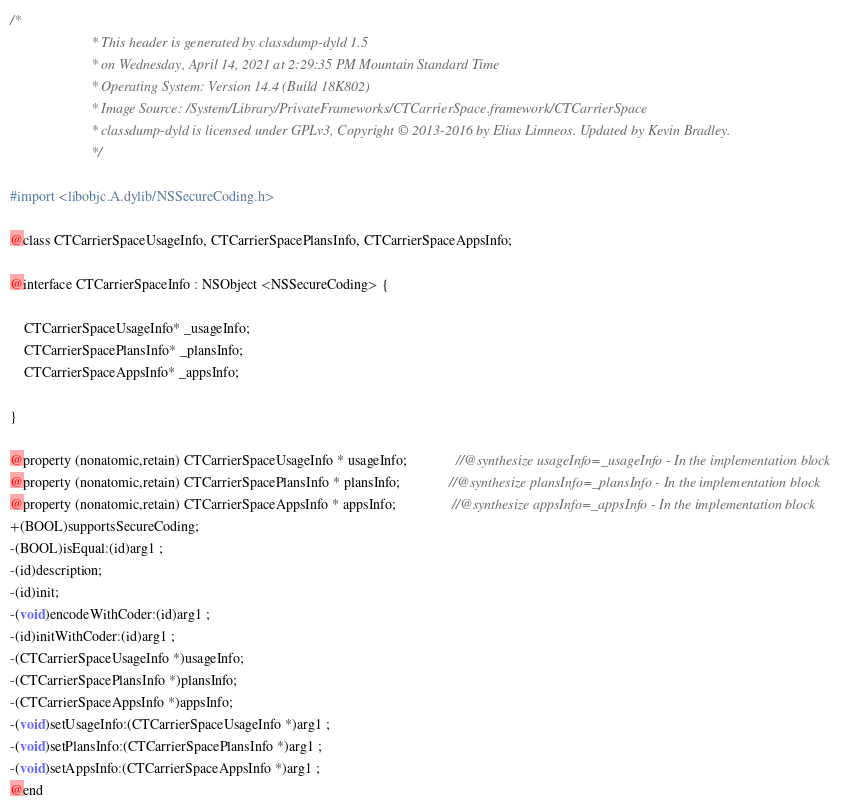Convert code to text. <code><loc_0><loc_0><loc_500><loc_500><_C_>/*
                       * This header is generated by classdump-dyld 1.5
                       * on Wednesday, April 14, 2021 at 2:29:35 PM Mountain Standard Time
                       * Operating System: Version 14.4 (Build 18K802)
                       * Image Source: /System/Library/PrivateFrameworks/CTCarrierSpace.framework/CTCarrierSpace
                       * classdump-dyld is licensed under GPLv3, Copyright © 2013-2016 by Elias Limneos. Updated by Kevin Bradley.
                       */

#import <libobjc.A.dylib/NSSecureCoding.h>

@class CTCarrierSpaceUsageInfo, CTCarrierSpacePlansInfo, CTCarrierSpaceAppsInfo;

@interface CTCarrierSpaceInfo : NSObject <NSSecureCoding> {

	CTCarrierSpaceUsageInfo* _usageInfo;
	CTCarrierSpacePlansInfo* _plansInfo;
	CTCarrierSpaceAppsInfo* _appsInfo;

}

@property (nonatomic,retain) CTCarrierSpaceUsageInfo * usageInfo;              //@synthesize usageInfo=_usageInfo - In the implementation block
@property (nonatomic,retain) CTCarrierSpacePlansInfo * plansInfo;              //@synthesize plansInfo=_plansInfo - In the implementation block
@property (nonatomic,retain) CTCarrierSpaceAppsInfo * appsInfo;                //@synthesize appsInfo=_appsInfo - In the implementation block
+(BOOL)supportsSecureCoding;
-(BOOL)isEqual:(id)arg1 ;
-(id)description;
-(id)init;
-(void)encodeWithCoder:(id)arg1 ;
-(id)initWithCoder:(id)arg1 ;
-(CTCarrierSpaceUsageInfo *)usageInfo;
-(CTCarrierSpacePlansInfo *)plansInfo;
-(CTCarrierSpaceAppsInfo *)appsInfo;
-(void)setUsageInfo:(CTCarrierSpaceUsageInfo *)arg1 ;
-(void)setPlansInfo:(CTCarrierSpacePlansInfo *)arg1 ;
-(void)setAppsInfo:(CTCarrierSpaceAppsInfo *)arg1 ;
@end

</code> 